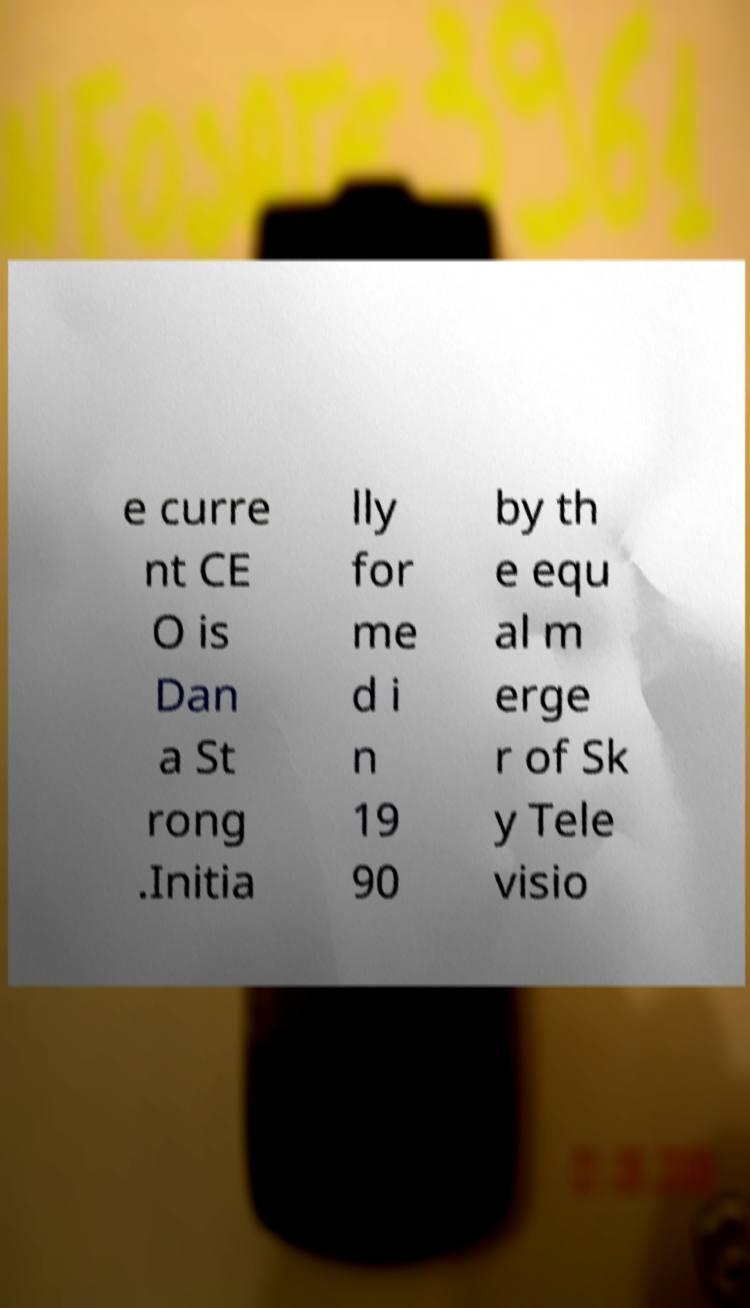Can you read and provide the text displayed in the image?This photo seems to have some interesting text. Can you extract and type it out for me? e curre nt CE O is Dan a St rong .Initia lly for me d i n 19 90 by th e equ al m erge r of Sk y Tele visio 